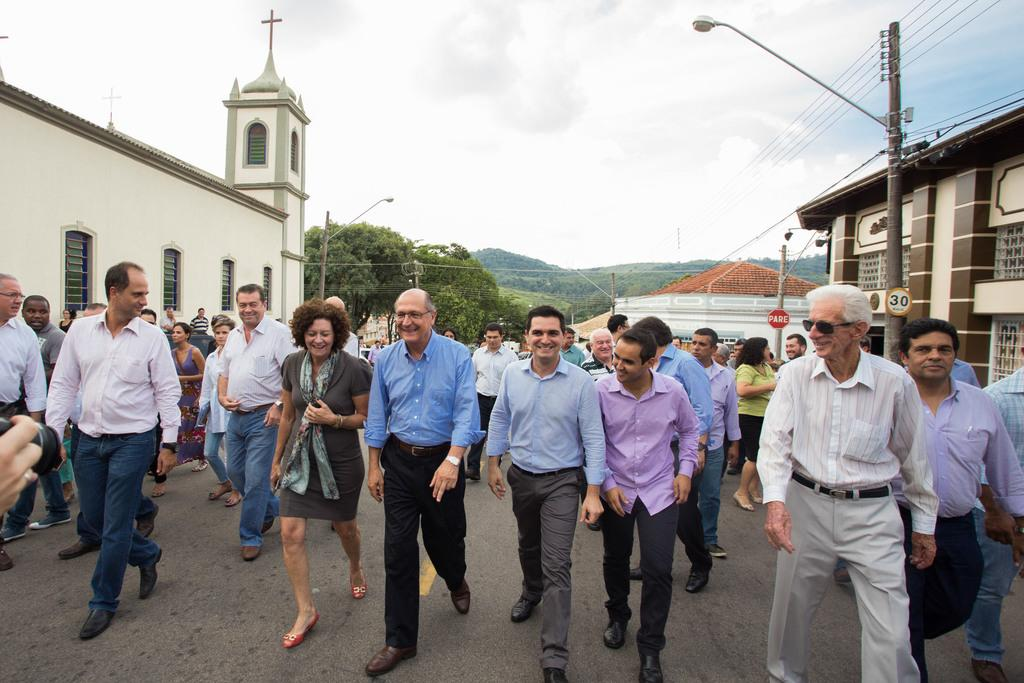What are the people in the image doing? The people in the image are walking on the road. What type of structures can be seen in the image? There are houses in the image. What objects are present in the image that are related to infrastructure? There are poles, boards, lights, and wires in the image. What type of vegetation is visible in the image? There are trees in the image. What is visible in the background of the image? The sky is visible in the background of the image, and there are clouds in the sky. Where is the bucket hanging from in the image? There is no bucket present in the image. What type of spring can be seen in the image? There is no spring present in the image. 